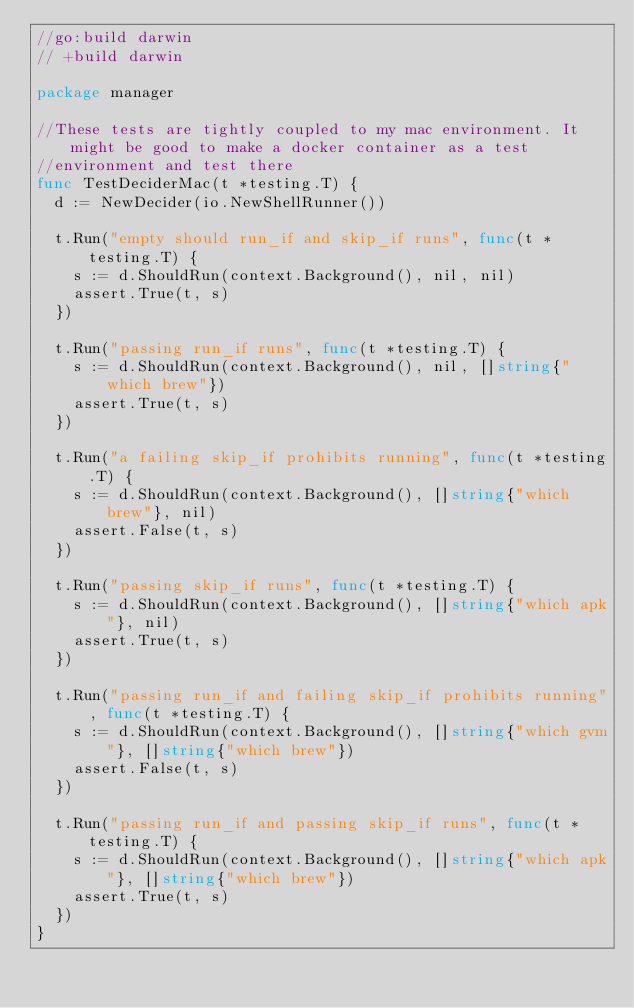<code> <loc_0><loc_0><loc_500><loc_500><_Go_>//go:build darwin
// +build darwin

package manager

//These tests are tightly coupled to my mac environment. It might be good to make a docker container as a test
//environment and test there
func TestDeciderMac(t *testing.T) {
	d := NewDecider(io.NewShellRunner())

	t.Run("empty should run_if and skip_if runs", func(t *testing.T) {
		s := d.ShouldRun(context.Background(), nil, nil)
		assert.True(t, s)
	})

	t.Run("passing run_if runs", func(t *testing.T) {
		s := d.ShouldRun(context.Background(), nil, []string{"which brew"})
		assert.True(t, s)
	})

	t.Run("a failing skip_if prohibits running", func(t *testing.T) {
		s := d.ShouldRun(context.Background(), []string{"which brew"}, nil)
		assert.False(t, s)
	})

	t.Run("passing skip_if runs", func(t *testing.T) {
		s := d.ShouldRun(context.Background(), []string{"which apk"}, nil)
		assert.True(t, s)
	})

	t.Run("passing run_if and failing skip_if prohibits running", func(t *testing.T) {
		s := d.ShouldRun(context.Background(), []string{"which gvm"}, []string{"which brew"})
		assert.False(t, s)
	})

	t.Run("passing run_if and passing skip_if runs", func(t *testing.T) {
		s := d.ShouldRun(context.Background(), []string{"which apk"}, []string{"which brew"})
		assert.True(t, s)
	})
}
</code> 